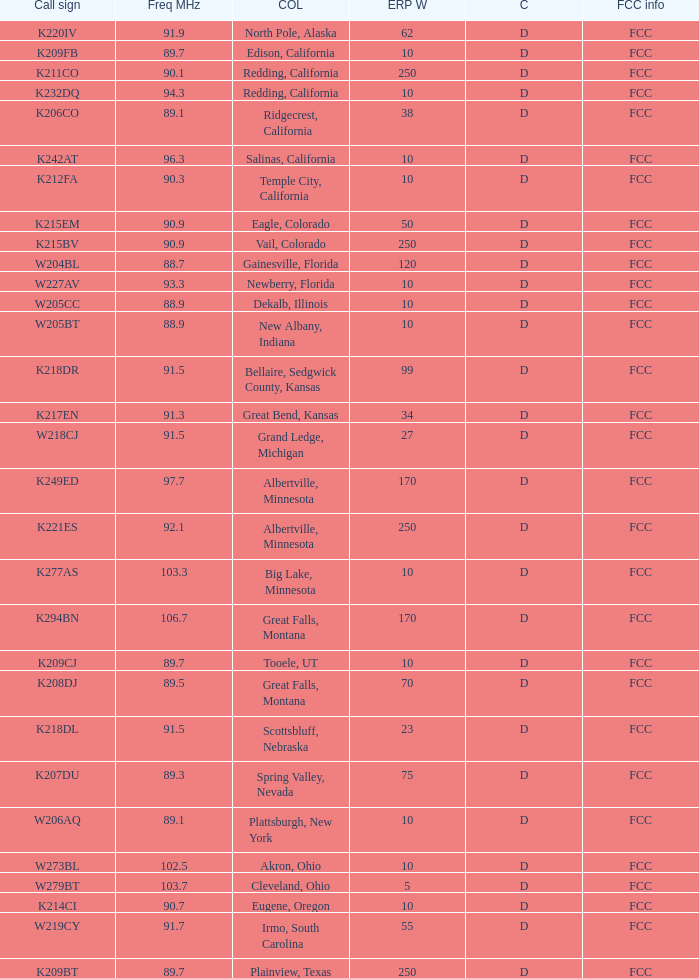What is the highest ERP W of an 89.1 frequency translator? 38.0. 